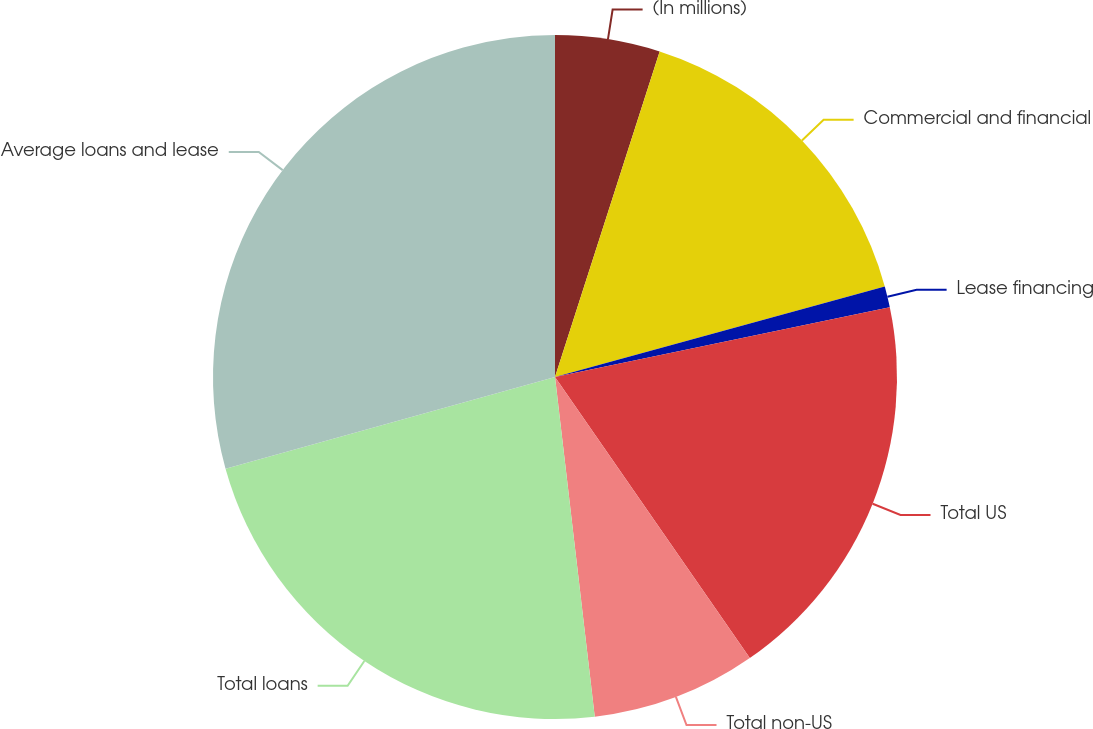Convert chart to OTSL. <chart><loc_0><loc_0><loc_500><loc_500><pie_chart><fcel>(In millions)<fcel>Commercial and financial<fcel>Lease financing<fcel>Total US<fcel>Total non-US<fcel>Total loans<fcel>Average loans and lease<nl><fcel>4.95%<fcel>15.78%<fcel>1.0%<fcel>18.62%<fcel>7.79%<fcel>22.53%<fcel>29.32%<nl></chart> 